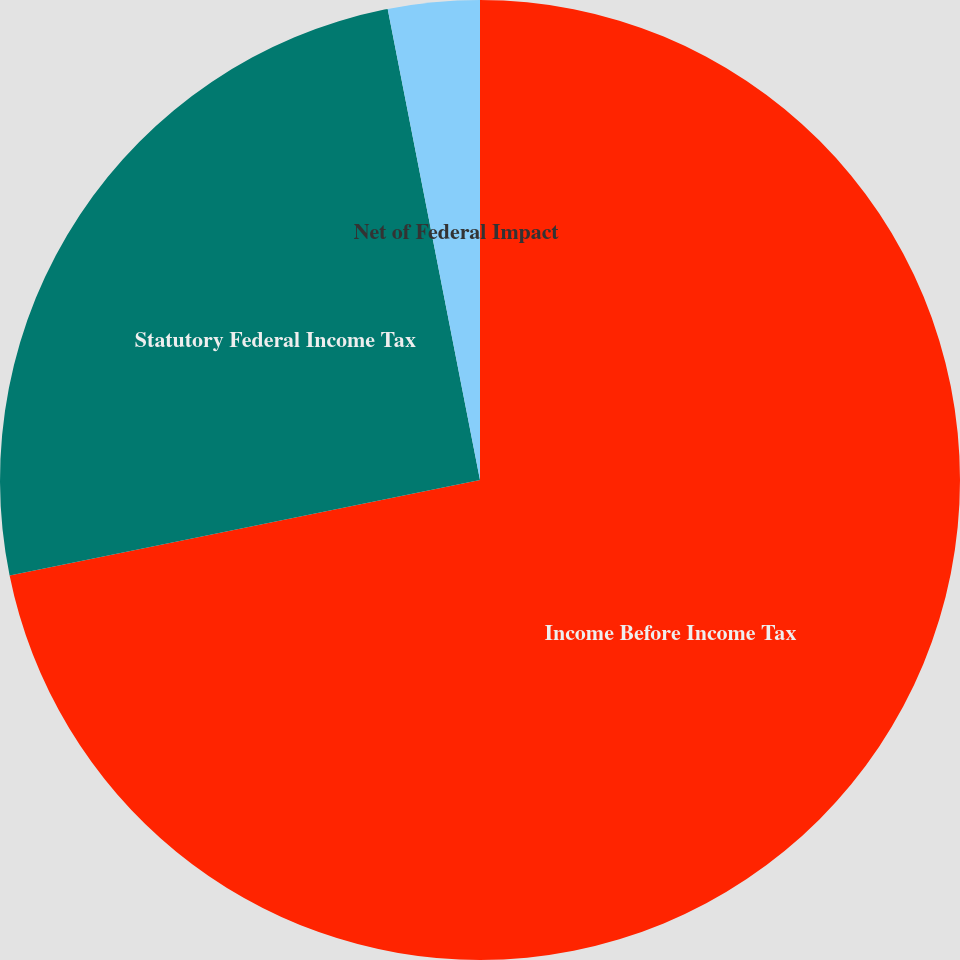Convert chart. <chart><loc_0><loc_0><loc_500><loc_500><pie_chart><fcel>Income Before Income Tax<fcel>Statutory Federal Income Tax<fcel>Net of Federal Impact<nl><fcel>71.81%<fcel>25.11%<fcel>3.08%<nl></chart> 